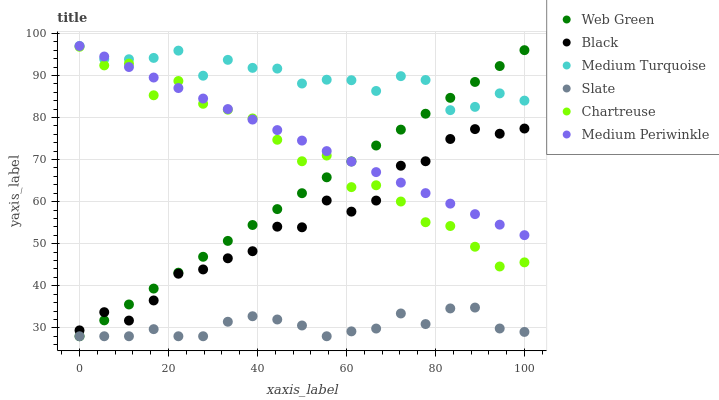Does Slate have the minimum area under the curve?
Answer yes or no. Yes. Does Medium Turquoise have the maximum area under the curve?
Answer yes or no. Yes. Does Medium Periwinkle have the minimum area under the curve?
Answer yes or no. No. Does Medium Periwinkle have the maximum area under the curve?
Answer yes or no. No. Is Web Green the smoothest?
Answer yes or no. Yes. Is Chartreuse the roughest?
Answer yes or no. Yes. Is Medium Periwinkle the smoothest?
Answer yes or no. No. Is Medium Periwinkle the roughest?
Answer yes or no. No. Does Slate have the lowest value?
Answer yes or no. Yes. Does Medium Periwinkle have the lowest value?
Answer yes or no. No. Does Medium Turquoise have the highest value?
Answer yes or no. Yes. Does Web Green have the highest value?
Answer yes or no. No. Is Slate less than Chartreuse?
Answer yes or no. Yes. Is Black greater than Slate?
Answer yes or no. Yes. Does Web Green intersect Slate?
Answer yes or no. Yes. Is Web Green less than Slate?
Answer yes or no. No. Is Web Green greater than Slate?
Answer yes or no. No. Does Slate intersect Chartreuse?
Answer yes or no. No. 